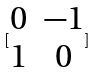<formula> <loc_0><loc_0><loc_500><loc_500>[ \begin{matrix} 0 & - 1 \\ 1 & 0 \end{matrix} ]</formula> 